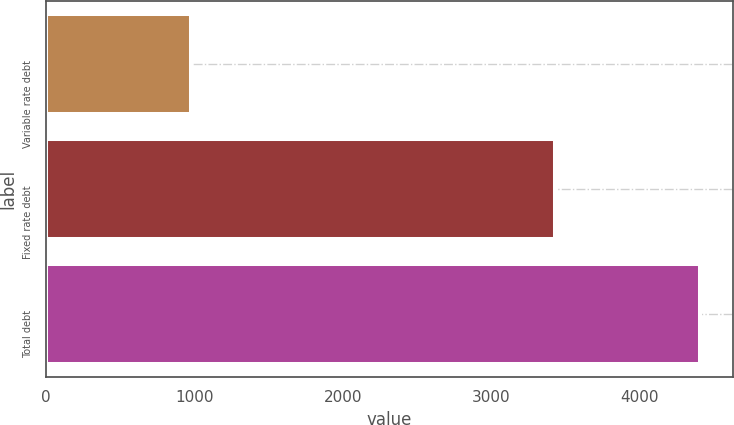Convert chart. <chart><loc_0><loc_0><loc_500><loc_500><bar_chart><fcel>Variable rate debt<fcel>Fixed rate debt<fcel>Total debt<nl><fcel>976.3<fcel>3427.1<fcel>4403.4<nl></chart> 